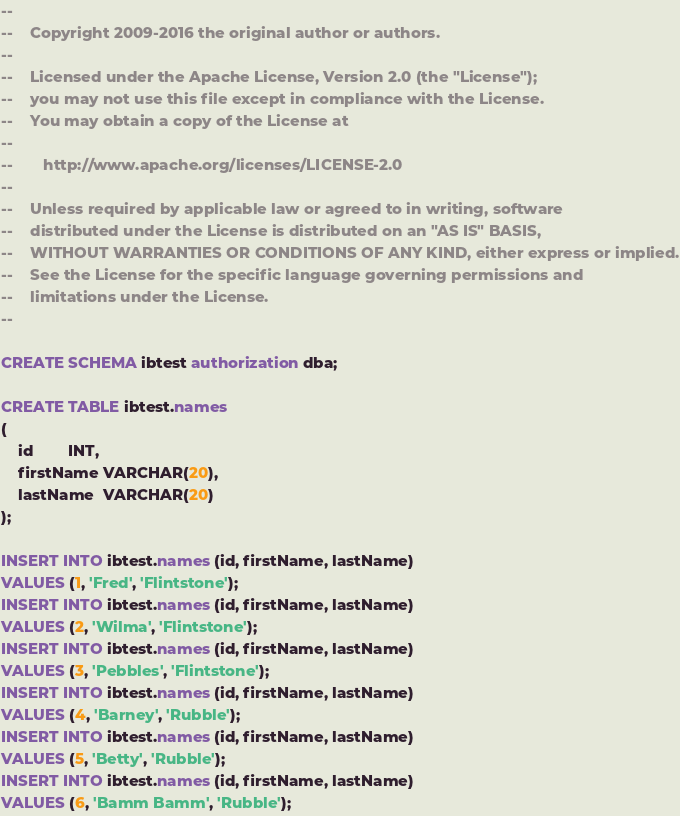Convert code to text. <code><loc_0><loc_0><loc_500><loc_500><_SQL_>--
--    Copyright 2009-2016 the original author or authors.
--
--    Licensed under the Apache License, Version 2.0 (the "License");
--    you may not use this file except in compliance with the License.
--    You may obtain a copy of the License at
--
--       http://www.apache.org/licenses/LICENSE-2.0
--
--    Unless required by applicable law or agreed to in writing, software
--    distributed under the License is distributed on an "AS IS" BASIS,
--    WITHOUT WARRANTIES OR CONDITIONS OF ANY KIND, either express or implied.
--    See the License for the specific language governing permissions and
--    limitations under the License.
--

CREATE SCHEMA ibtest authorization dba;

CREATE TABLE ibtest.names
(
    id        INT,
    firstName VARCHAR(20),
    lastName  VARCHAR(20)
);

INSERT INTO ibtest.names (id, firstName, lastName)
VALUES (1, 'Fred', 'Flintstone');
INSERT INTO ibtest.names (id, firstName, lastName)
VALUES (2, 'Wilma', 'Flintstone');
INSERT INTO ibtest.names (id, firstName, lastName)
VALUES (3, 'Pebbles', 'Flintstone');
INSERT INTO ibtest.names (id, firstName, lastName)
VALUES (4, 'Barney', 'Rubble');
INSERT INTO ibtest.names (id, firstName, lastName)
VALUES (5, 'Betty', 'Rubble');
INSERT INTO ibtest.names (id, firstName, lastName)
VALUES (6, 'Bamm Bamm', 'Rubble');
</code> 